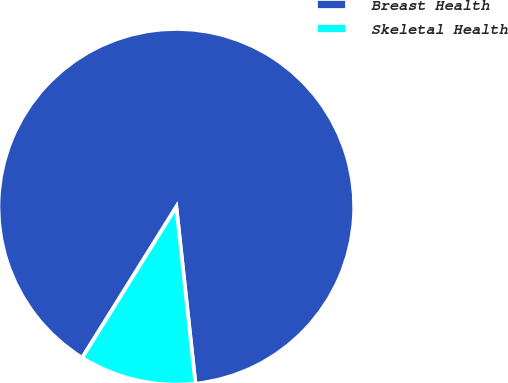Convert chart. <chart><loc_0><loc_0><loc_500><loc_500><pie_chart><fcel>Breast Health<fcel>Skeletal Health<nl><fcel>89.41%<fcel>10.59%<nl></chart> 